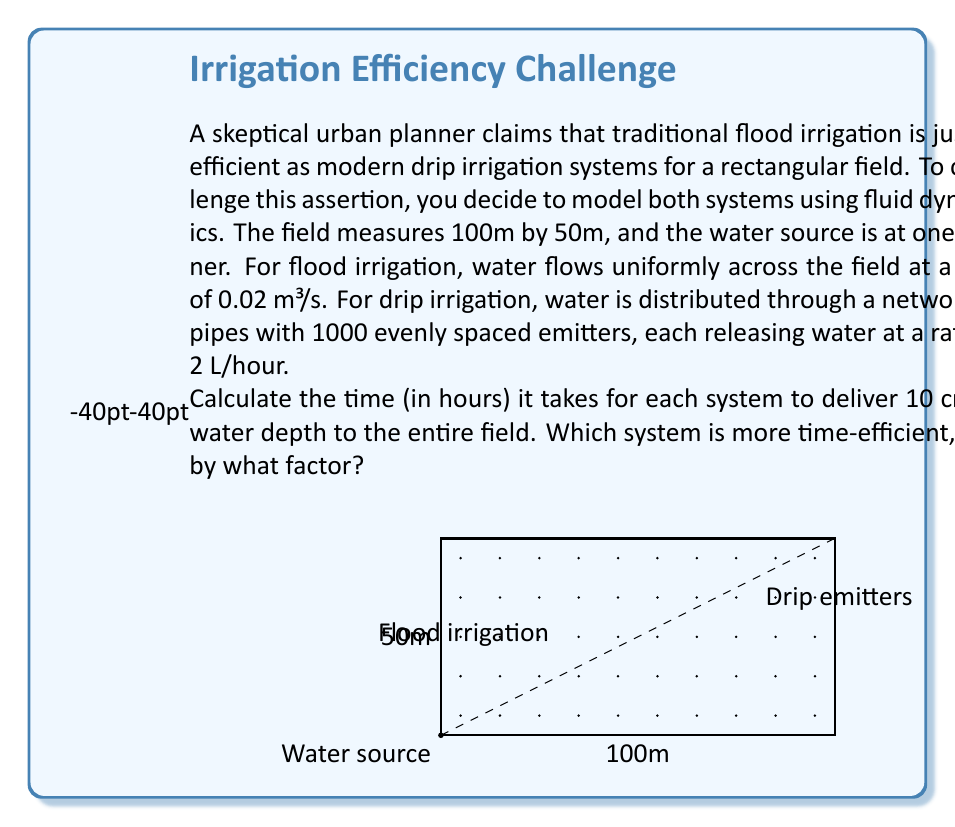Solve this math problem. Let's approach this problem step by step:

1) First, calculate the volume of water needed to cover the field with 10 cm depth:
   $$V = 100\text{ m} \times 50\text{ m} \times 0.1\text{ m} = 500\text{ m}^3$$

2) For flood irrigation:
   - Water flow rate: $Q_f = 0.02\text{ m}^3/\text{s}$
   - Time required: $t_f = \frac{V}{Q_f} = \frac{500\text{ m}^3}{0.02\text{ m}^3/\text{s}} = 25000\text{ s} = 6.94\text{ hours}$

3) For drip irrigation:
   - Number of emitters: $n = 1000$
   - Flow rate per emitter: $q_d = 2\text{ L/hour} = 0.002\text{ m}^3/\text{hour}$
   - Total flow rate: $Q_d = n \times q_d = 1000 \times 0.002 = 2\text{ m}^3/\text{hour}$
   - Time required: $t_d = \frac{V}{Q_d} = \frac{500\text{ m}^3}{2\text{ m}^3/\text{hour}} = 250\text{ hours}$

4) Efficiency comparison:
   - Time ratio: $\frac{t_f}{t_d} = \frac{6.94}{250} = 0.02776$
   - Flood irrigation is $\frac{1}{0.02776} \approx 36$ times faster than drip irrigation in this scenario.

However, it's important to note that while flood irrigation is faster in this model, it's generally less water-efficient due to factors like evaporation and runoff, which aren't accounted for in this simplified calculation.
Answer: Flood: 6.94 hours, Drip: 250 hours. Flood is 36 times faster. 